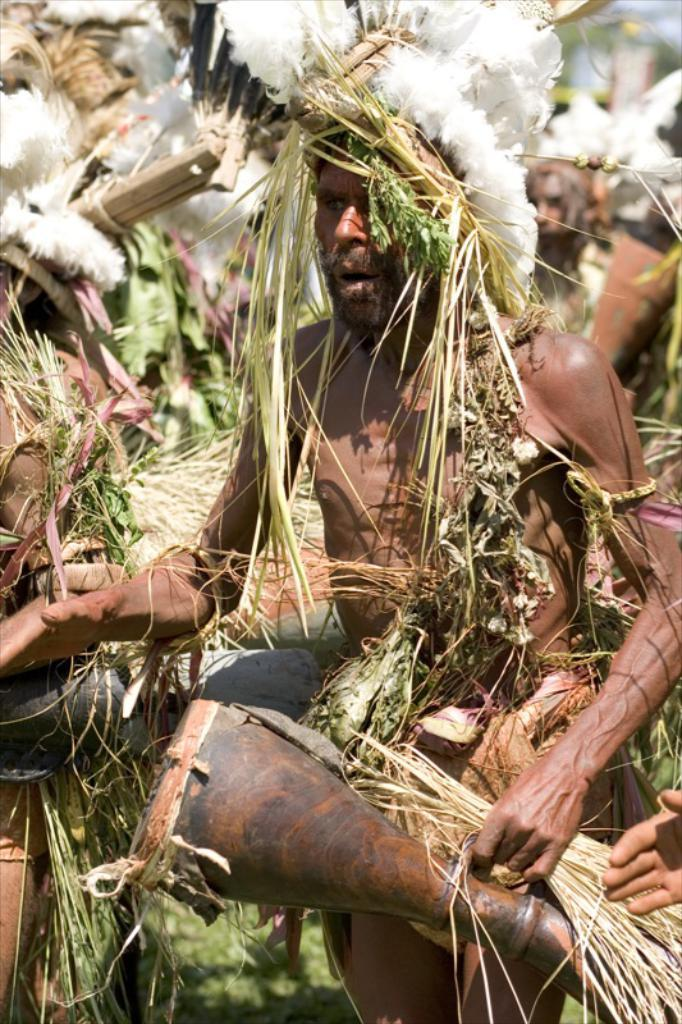What is present in the image? There are people in the image. What are the people wearing? The people are wearing costumes. Can you see any ducks wearing gold hats in the image? There are no ducks or gold hats present in the image. 